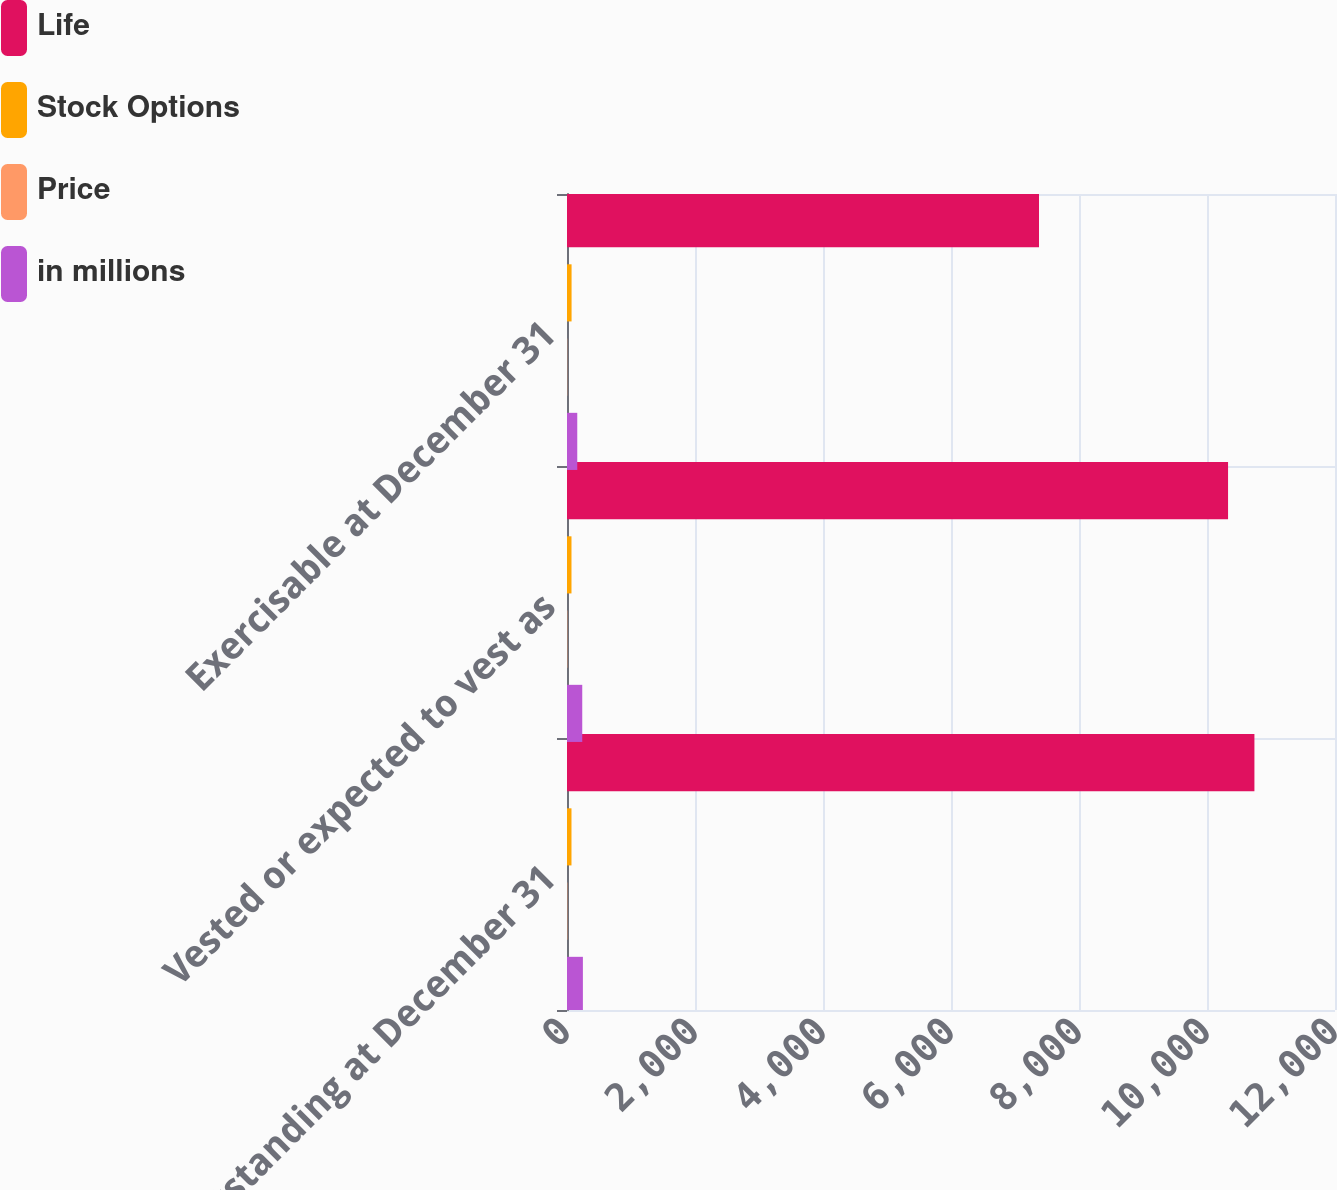Convert chart to OTSL. <chart><loc_0><loc_0><loc_500><loc_500><stacked_bar_chart><ecel><fcel>Outstanding at December 31<fcel>Vested or expected to vest as<fcel>Exercisable at December 31<nl><fcel>Life<fcel>10741<fcel>10329<fcel>7375<nl><fcel>Stock Options<fcel>70.06<fcel>70.12<fcel>71.44<nl><fcel>Price<fcel>5<fcel>4.9<fcel>3.5<nl><fcel>in millions<fcel>248.4<fcel>238.3<fcel>160.4<nl></chart> 